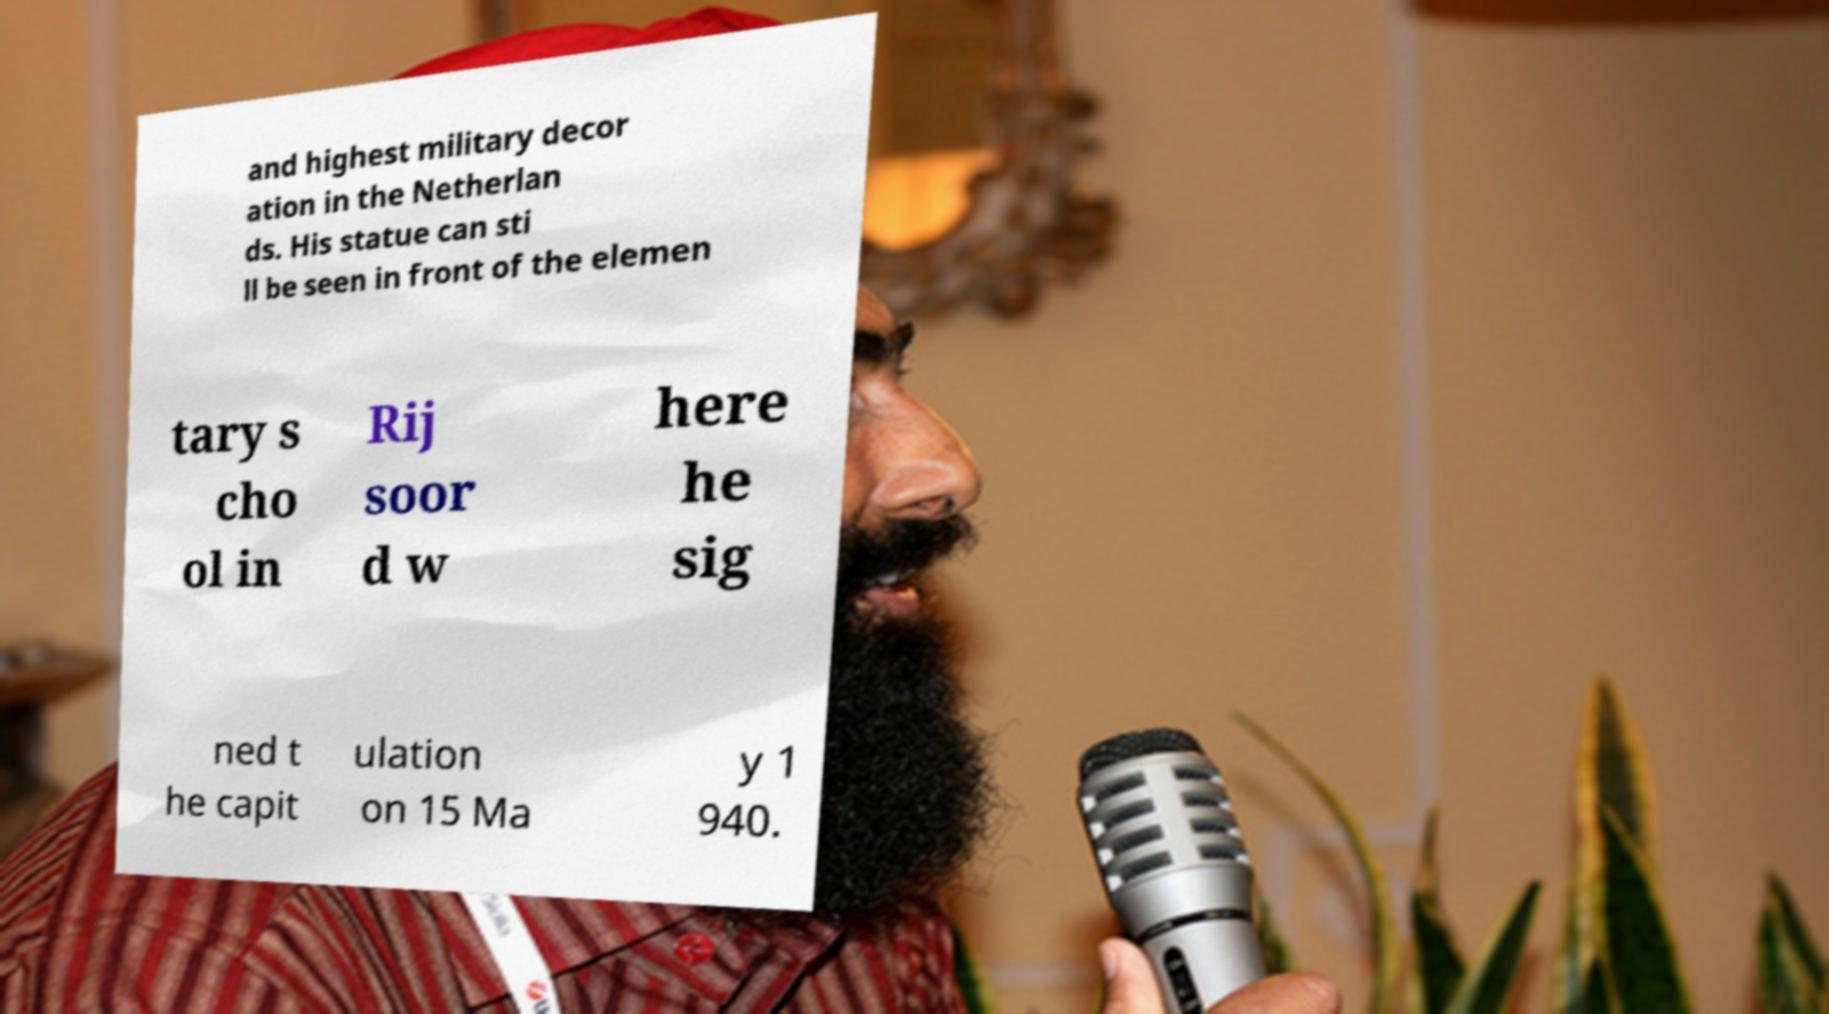I need the written content from this picture converted into text. Can you do that? and highest military decor ation in the Netherlan ds. His statue can sti ll be seen in front of the elemen tary s cho ol in Rij soor d w here he sig ned t he capit ulation on 15 Ma y 1 940. 